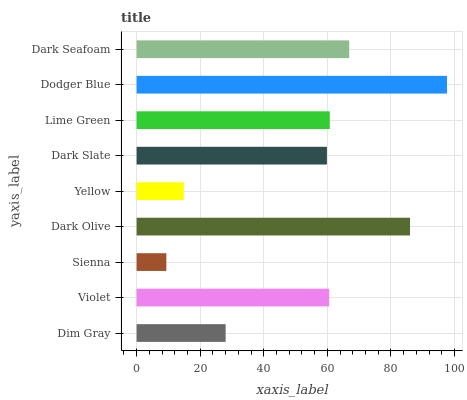Is Sienna the minimum?
Answer yes or no. Yes. Is Dodger Blue the maximum?
Answer yes or no. Yes. Is Violet the minimum?
Answer yes or no. No. Is Violet the maximum?
Answer yes or no. No. Is Violet greater than Dim Gray?
Answer yes or no. Yes. Is Dim Gray less than Violet?
Answer yes or no. Yes. Is Dim Gray greater than Violet?
Answer yes or no. No. Is Violet less than Dim Gray?
Answer yes or no. No. Is Violet the high median?
Answer yes or no. Yes. Is Violet the low median?
Answer yes or no. Yes. Is Dodger Blue the high median?
Answer yes or no. No. Is Dim Gray the low median?
Answer yes or no. No. 